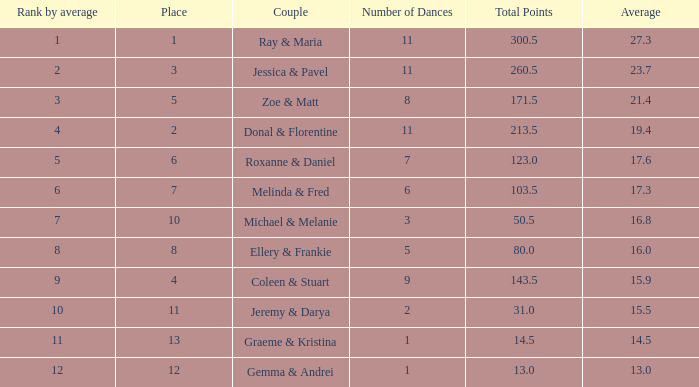What is the pair's name with an average of 1 Coleen & Stuart. 